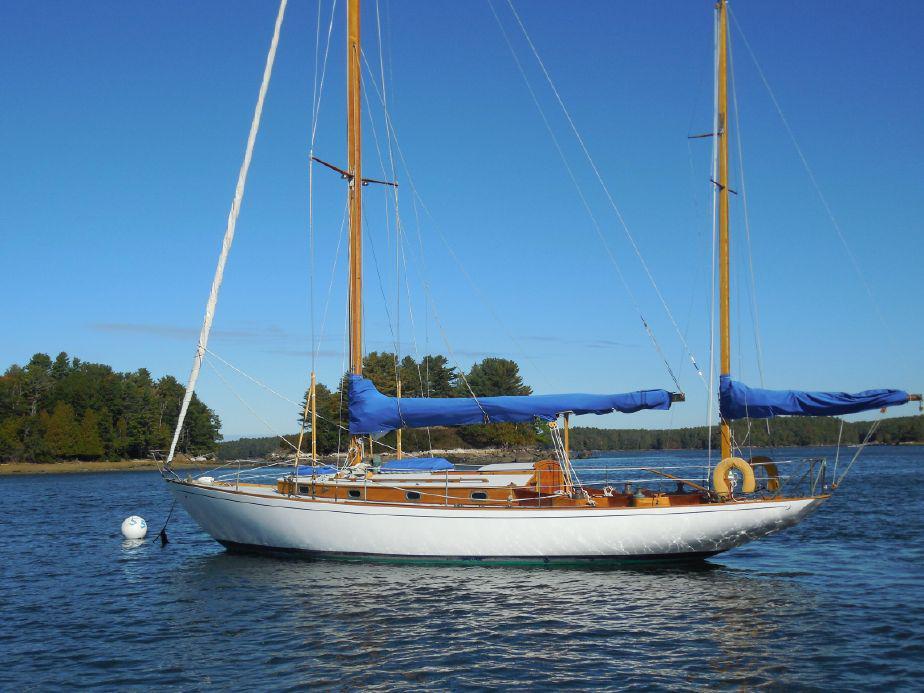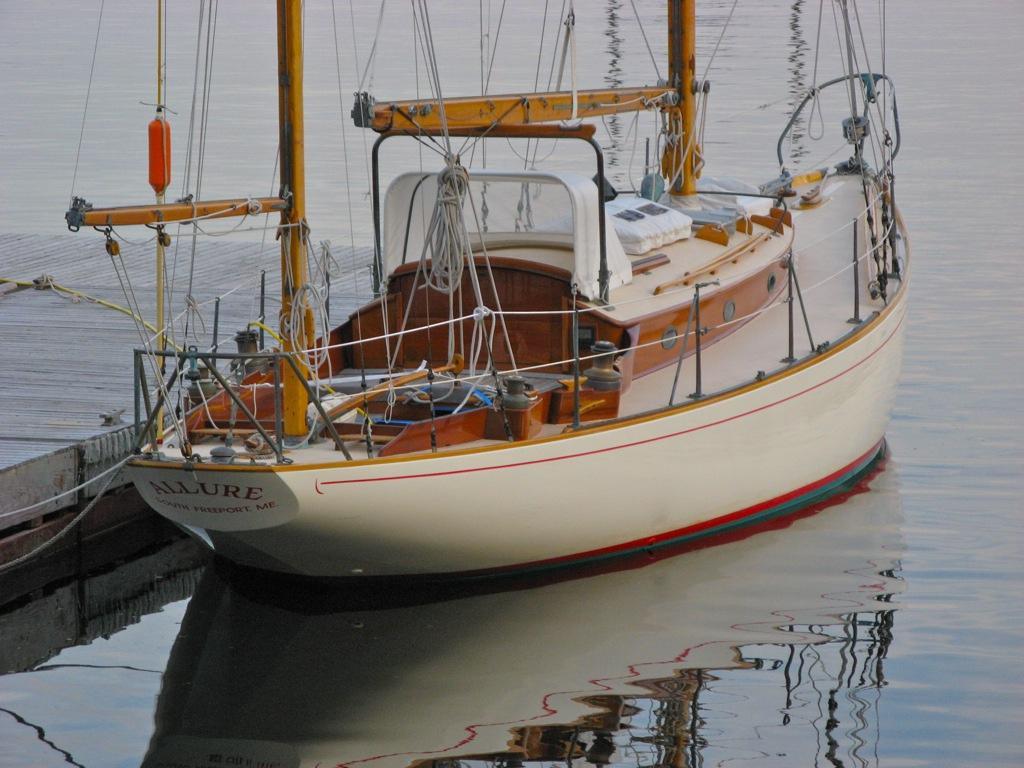The first image is the image on the left, the second image is the image on the right. Given the left and right images, does the statement "Neither boat has its sails up." hold true? Answer yes or no. Yes. 